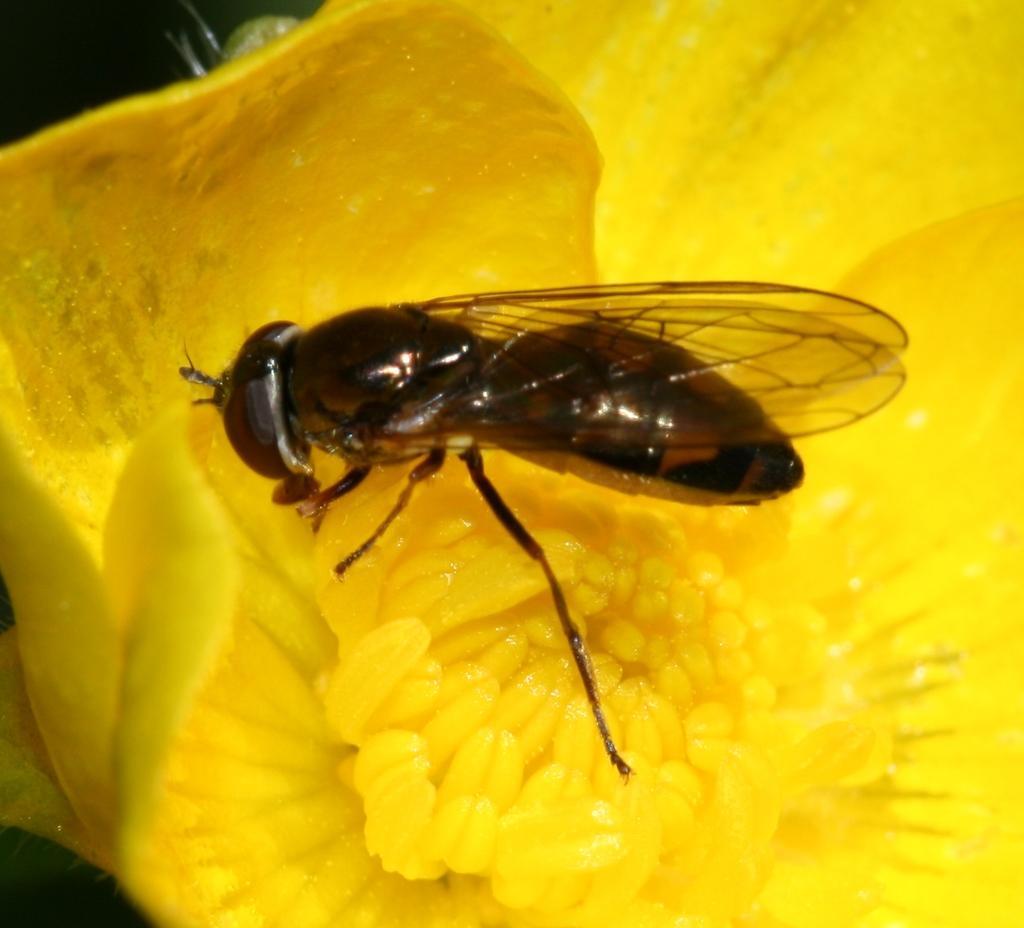Could you give a brief overview of what you see in this image? In this image there is a fly on the flower. 